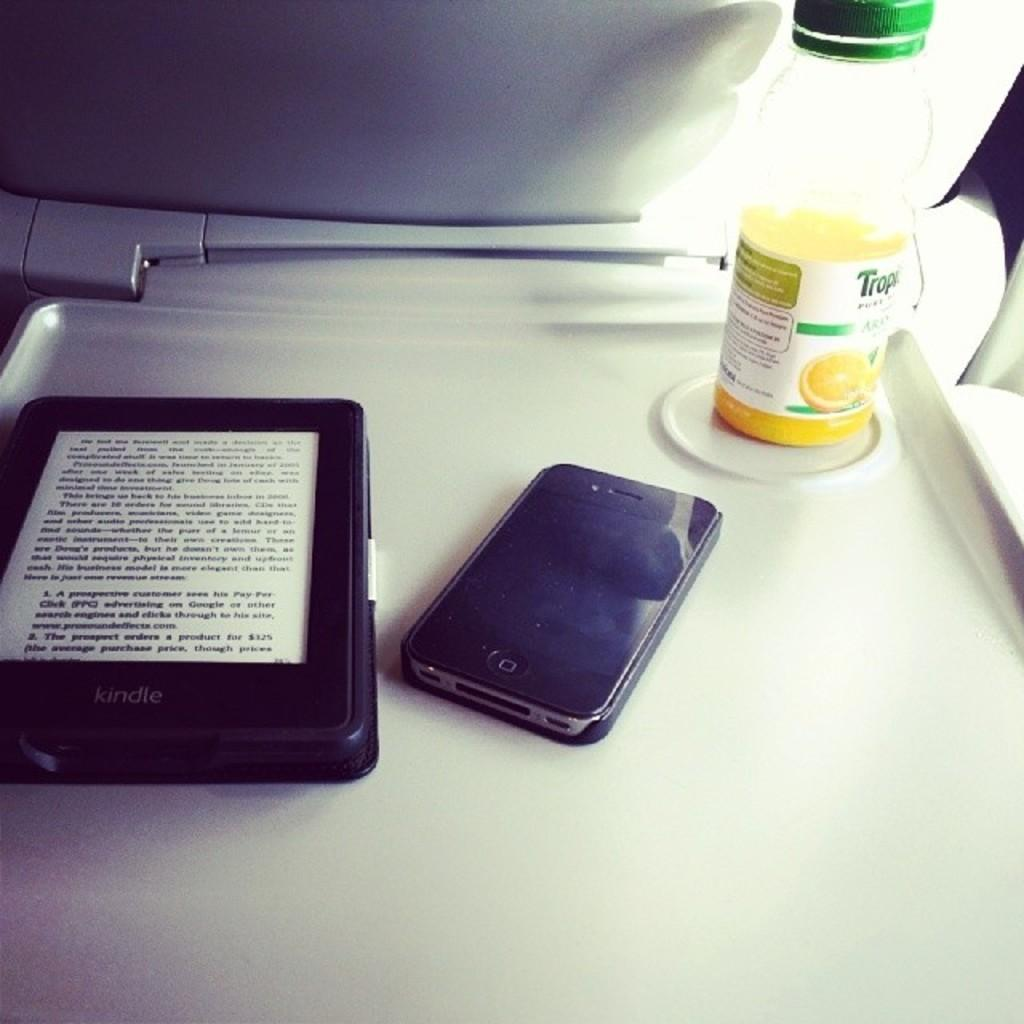<image>
Offer a succinct explanation of the picture presented. A phone, tablet and a half full bottle of tropicana. 